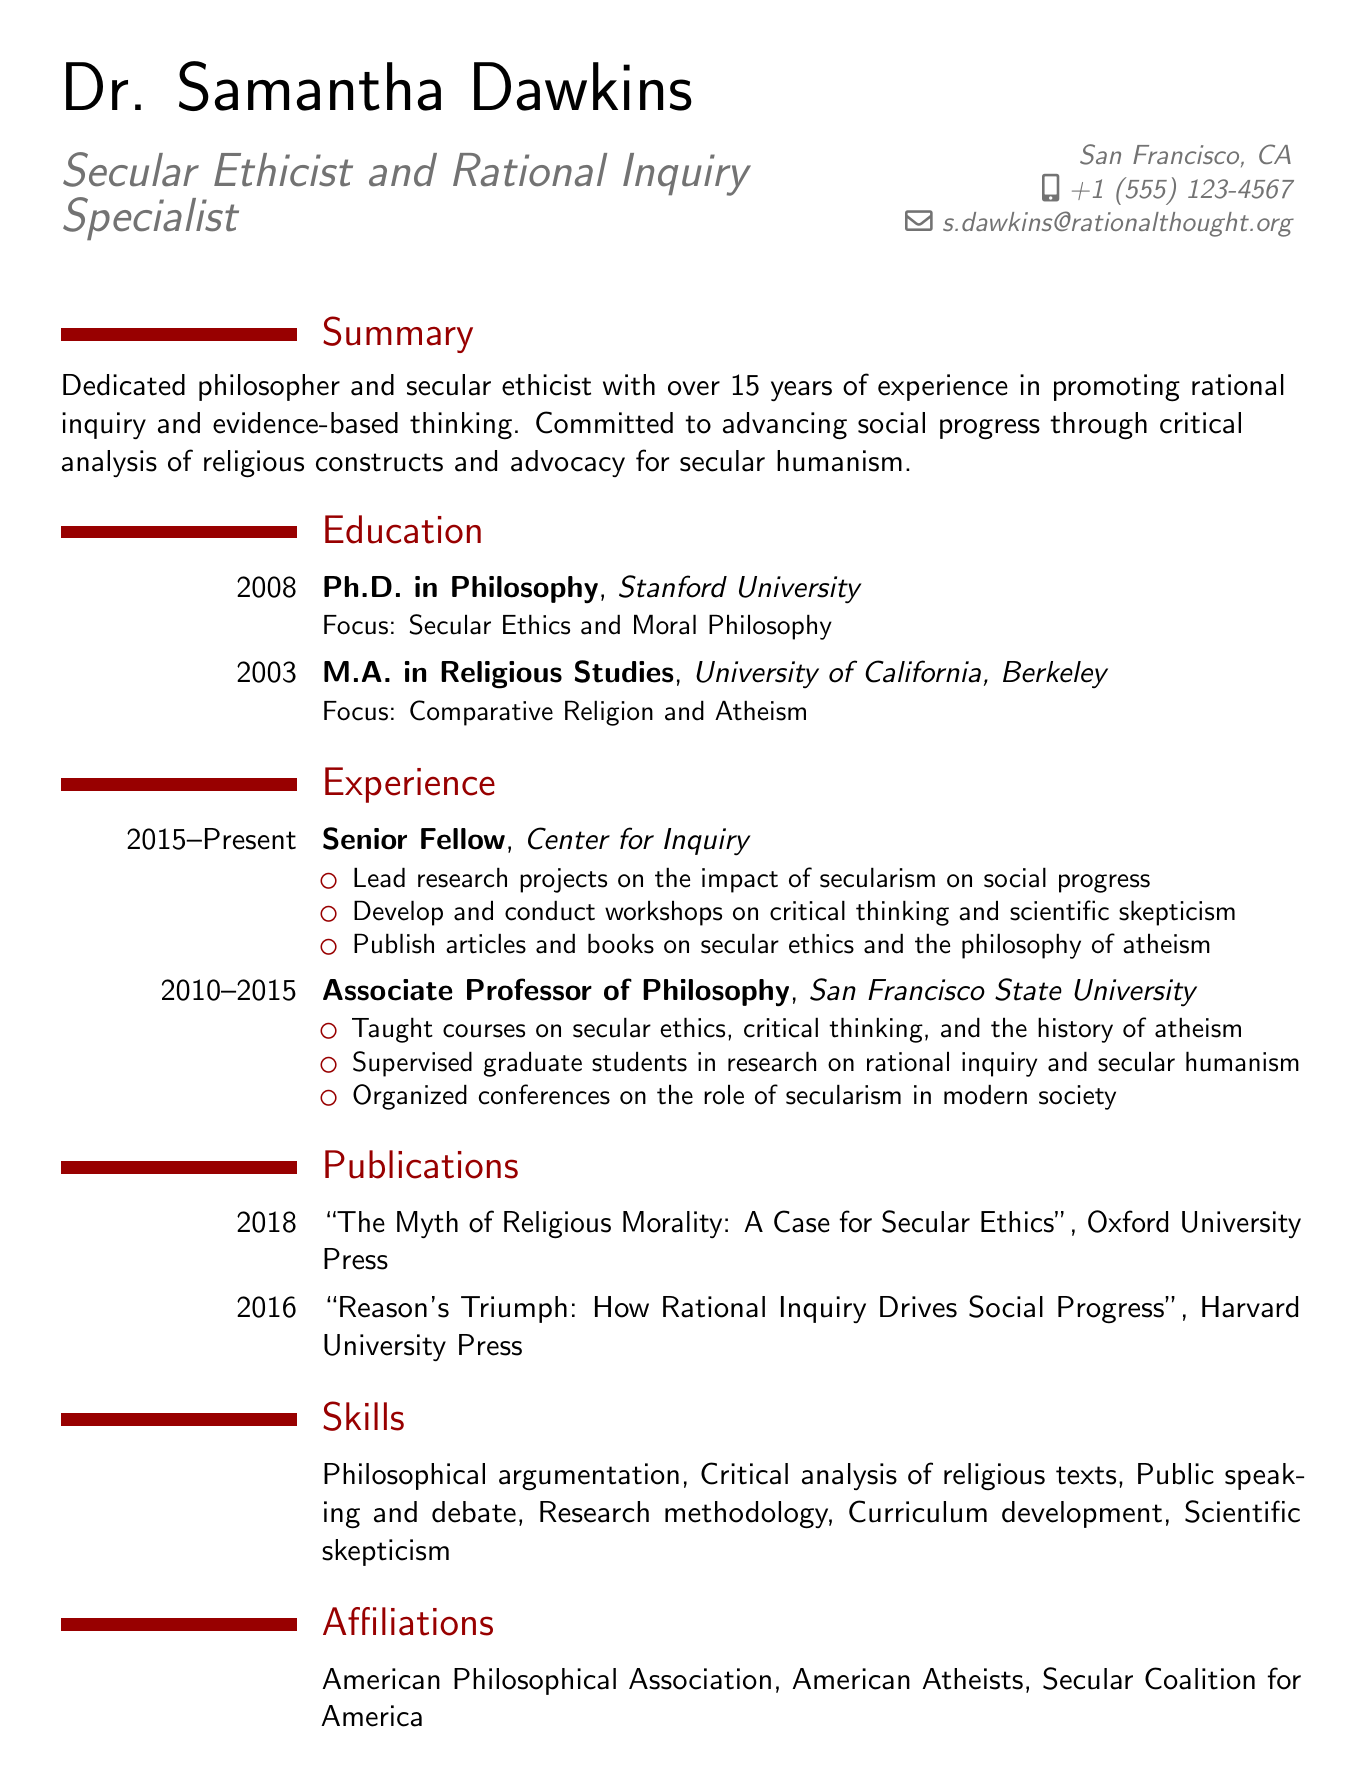What is the name of the candidate? The name of the candidate is highlighted at the top of the document under personal information.
Answer: Dr. Samantha Dawkins What is Dr. Dawkins' email address? The email address is provided in the contact section of the resume.
Answer: s.dawkins@rationalthought.org What degree did Dr. Dawkins earn in 2008? The degree is mentioned in the education section along with the year it was earned.
Answer: Ph.D. in Philosophy Which organization does Dr. Dawkins currently work for? The current position is listed in the experience section, together with the organization.
Answer: Center for Inquiry What is the focus of Dr. Dawkins' Ph.D. program? The focus of the degree is specified in the education section of the document.
Answer: Secular Ethics and Moral Philosophy How many years of experience does Dr. Dawkins have? The summary section states the amount of experience Dr. Dawkins has in her field.
Answer: Over 15 years What type of workshops does Dr. Dawkins conduct? The responsibilities in her current role detail the types of workshops she develops.
Answer: Critical thinking and scientific skepticism Which publishing house released Dr. Dawkins' book in 2018? The publication section provides the name of the publisher for her 2018 book.
Answer: Oxford University Press What is the main theme of Dr. Dawkins' second published book? The title of the book provides insight into its main theme, which can be inferred from the publication section.
Answer: Rational Inquiry Drives Social Progress 